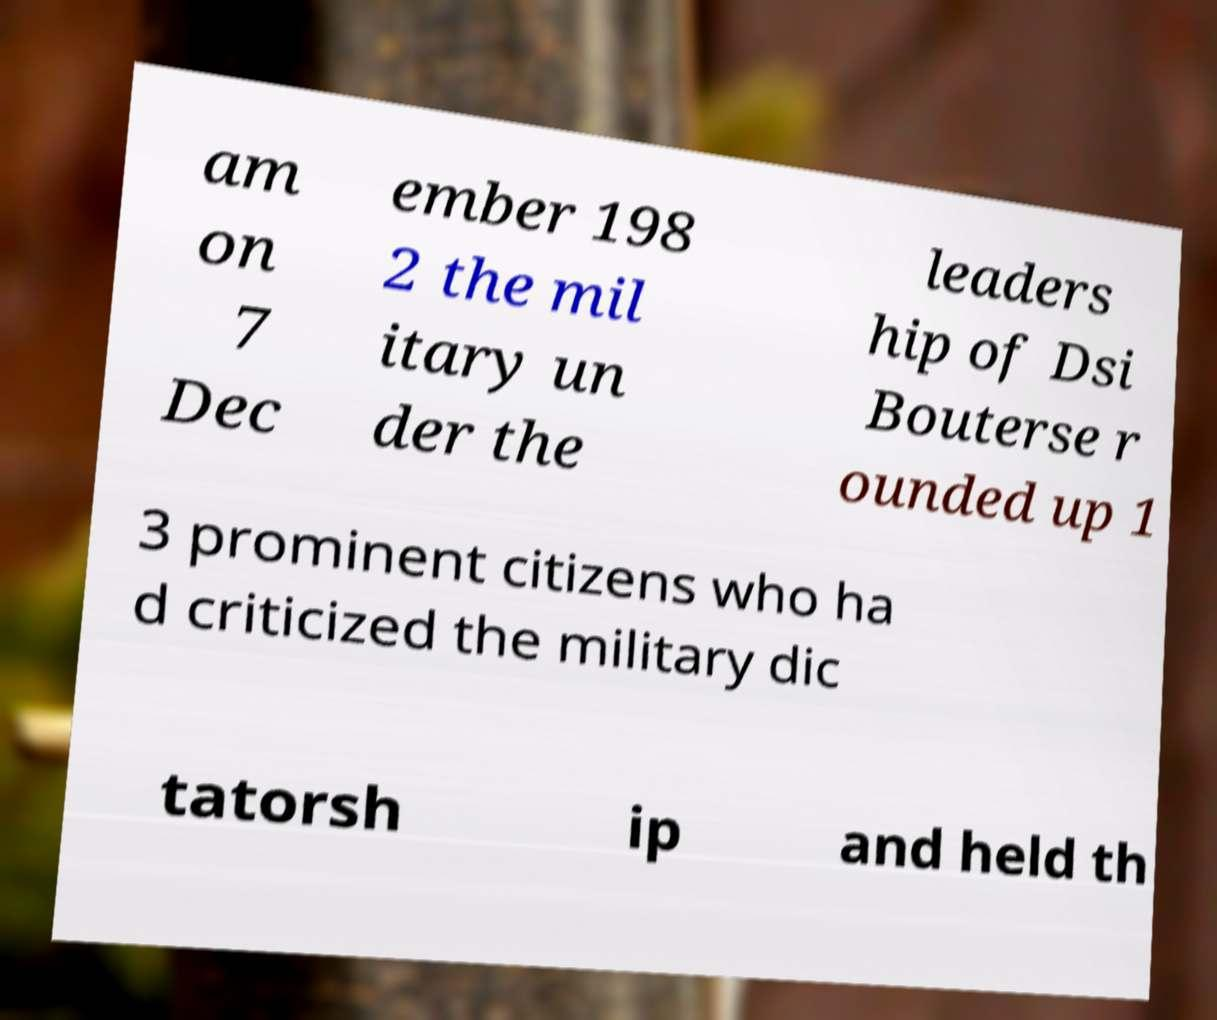Can you read and provide the text displayed in the image?This photo seems to have some interesting text. Can you extract and type it out for me? am on 7 Dec ember 198 2 the mil itary un der the leaders hip of Dsi Bouterse r ounded up 1 3 prominent citizens who ha d criticized the military dic tatorsh ip and held th 